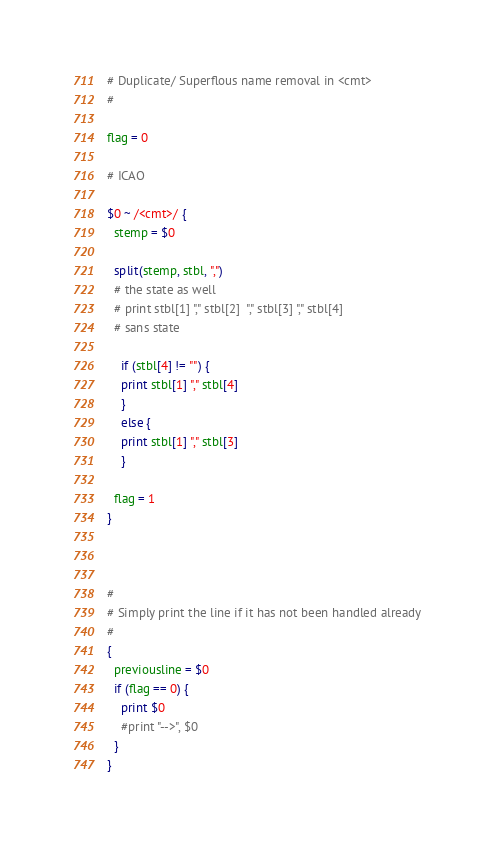Convert code to text. <code><loc_0><loc_0><loc_500><loc_500><_Awk_># Duplicate/ Superflous name removal in <cmt>
#

flag = 0

# ICAO

$0 ~ /<cmt>/ {
  stemp = $0
	
  split(stemp, stbl, ",")
  # the state as well	
  # print stbl[1] "," stbl[2]  "," stbl[3] "," stbl[4]
  # sans state 
	
	if (stbl[4] != "") {
    print stbl[1] "," stbl[4]
	}
	else {
    print stbl[1] "," stbl[3]
	}
	
  flag = 1
}
	


#
# Simply print the line if it has not been handled already
#
{
  previousline = $0
  if (flag == 0) {
    print $0
    #print "-->", $0
  }
}



</code> 